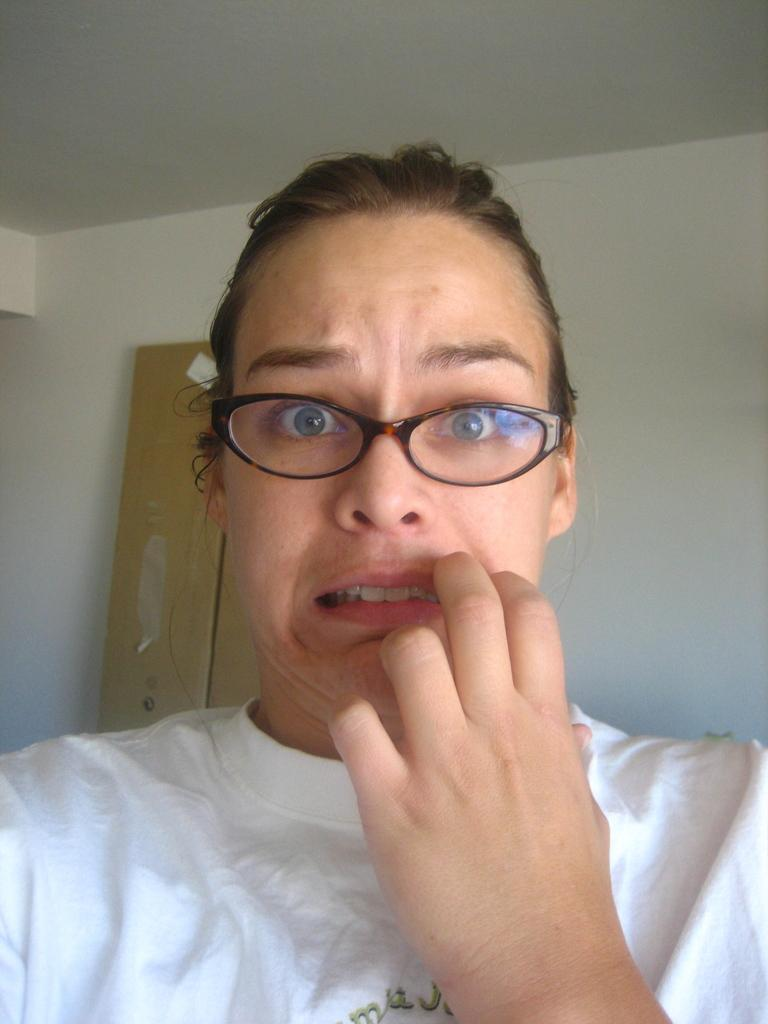Who is the main subject in the picture? There is a woman in the picture. What is the woman wearing? The woman is wearing white. Are there any accessories visible on the woman? Yes, the woman is wearing spectacles. What is the woman doing in the picture? The woman is making a weird face. What type of iron can be seen in the woman's hair in the image? There is no iron visible in the image, and the woman's hair is not mentioned in the provided facts. 